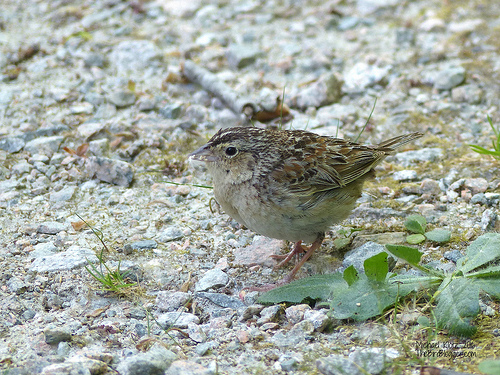<image>
Can you confirm if the bird is on the ground? Yes. Looking at the image, I can see the bird is positioned on top of the ground, with the ground providing support. 